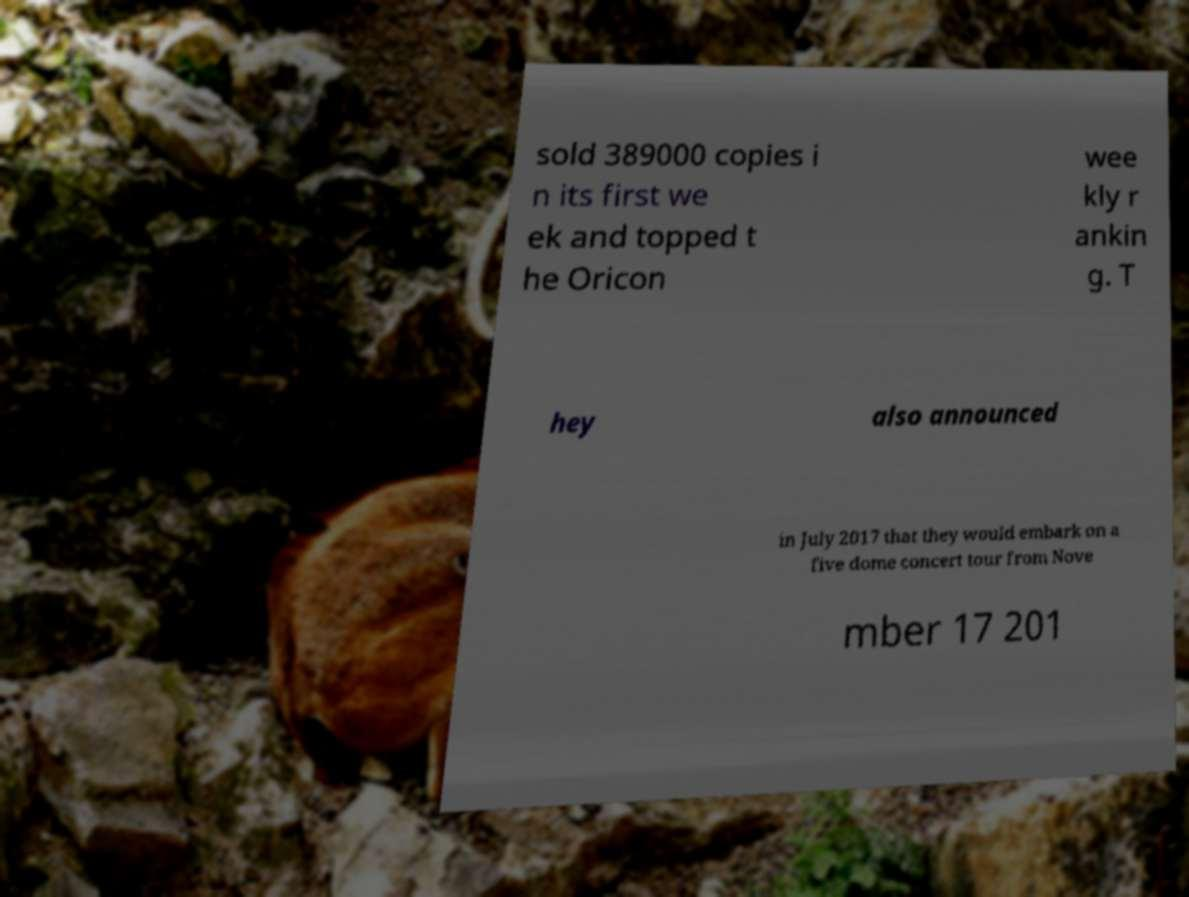I need the written content from this picture converted into text. Can you do that? sold 389000 copies i n its first we ek and topped t he Oricon wee kly r ankin g. T hey also announced in July 2017 that they would embark on a five dome concert tour from Nove mber 17 201 